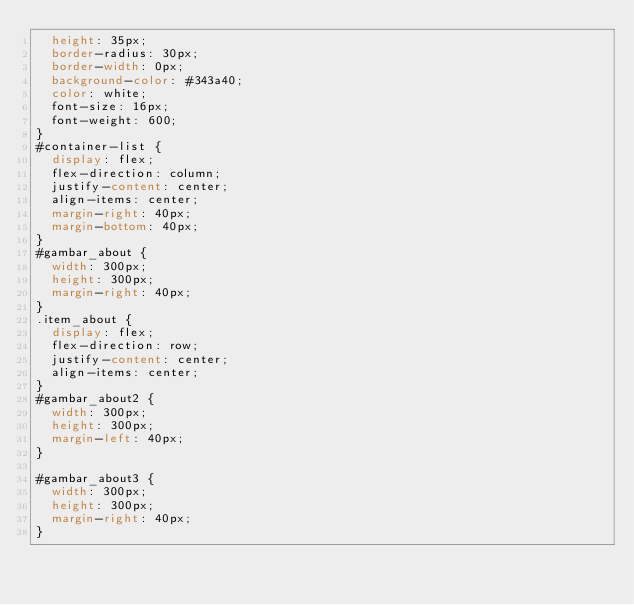<code> <loc_0><loc_0><loc_500><loc_500><_CSS_>  height: 35px;
  border-radius: 30px;
  border-width: 0px;
  background-color: #343a40;
  color: white;
  font-size: 16px;
  font-weight: 600;
}
#container-list {
  display: flex;
  flex-direction: column;
  justify-content: center;
  align-items: center;
  margin-right: 40px;
  margin-bottom: 40px;
}
#gambar_about {
  width: 300px;
  height: 300px;
  margin-right: 40px;
}
.item_about {
  display: flex;
  flex-direction: row;
  justify-content: center;
  align-items: center;
}
#gambar_about2 {
  width: 300px;
  height: 300px;
  margin-left: 40px;
}

#gambar_about3 {
  width: 300px;
  height: 300px;
  margin-right: 40px;
}
</code> 